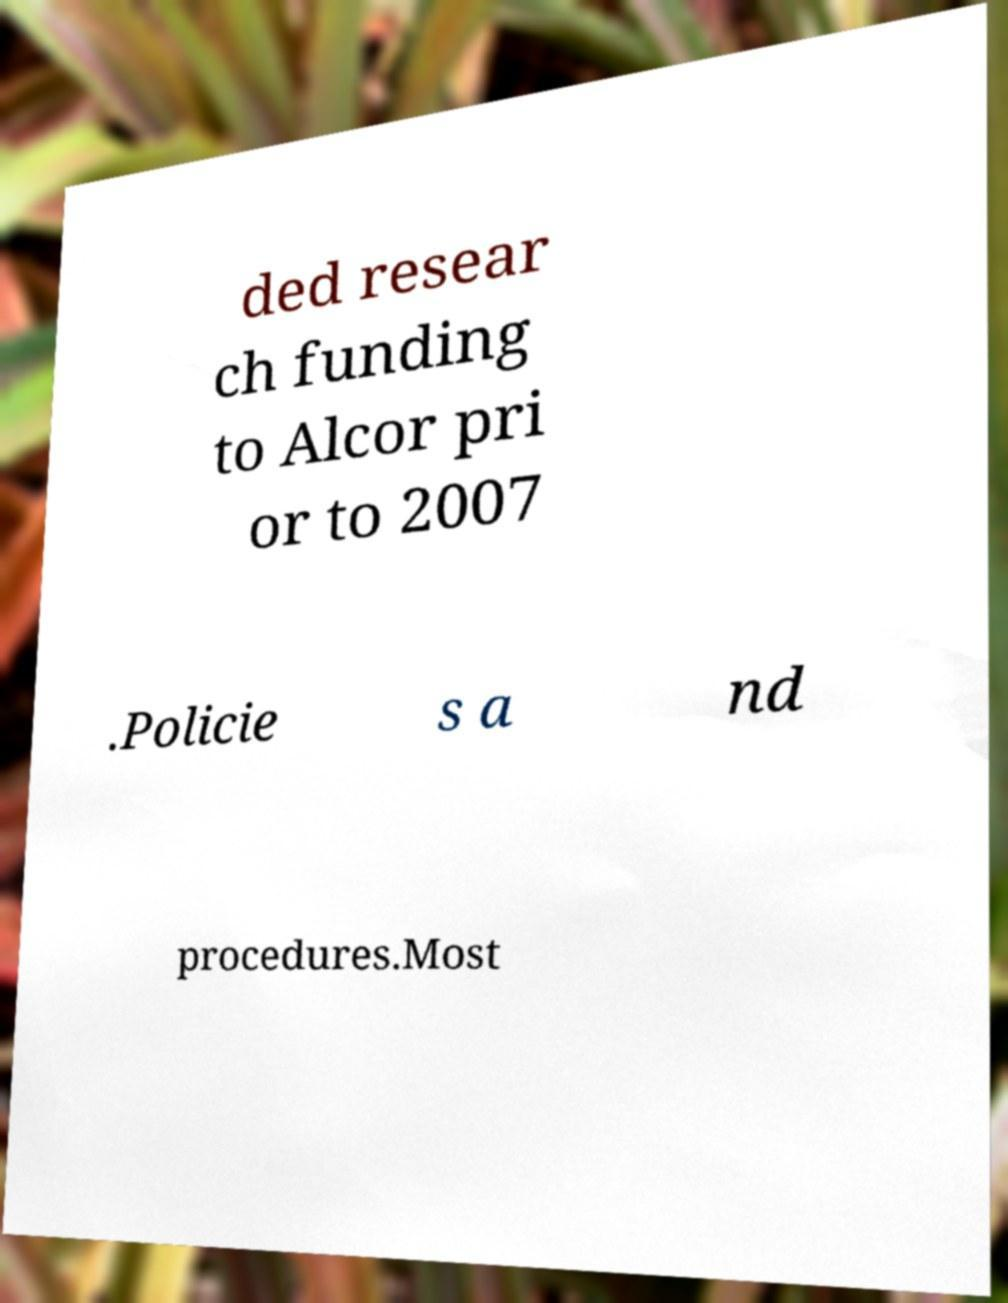Please read and relay the text visible in this image. What does it say? ded resear ch funding to Alcor pri or to 2007 .Policie s a nd procedures.Most 